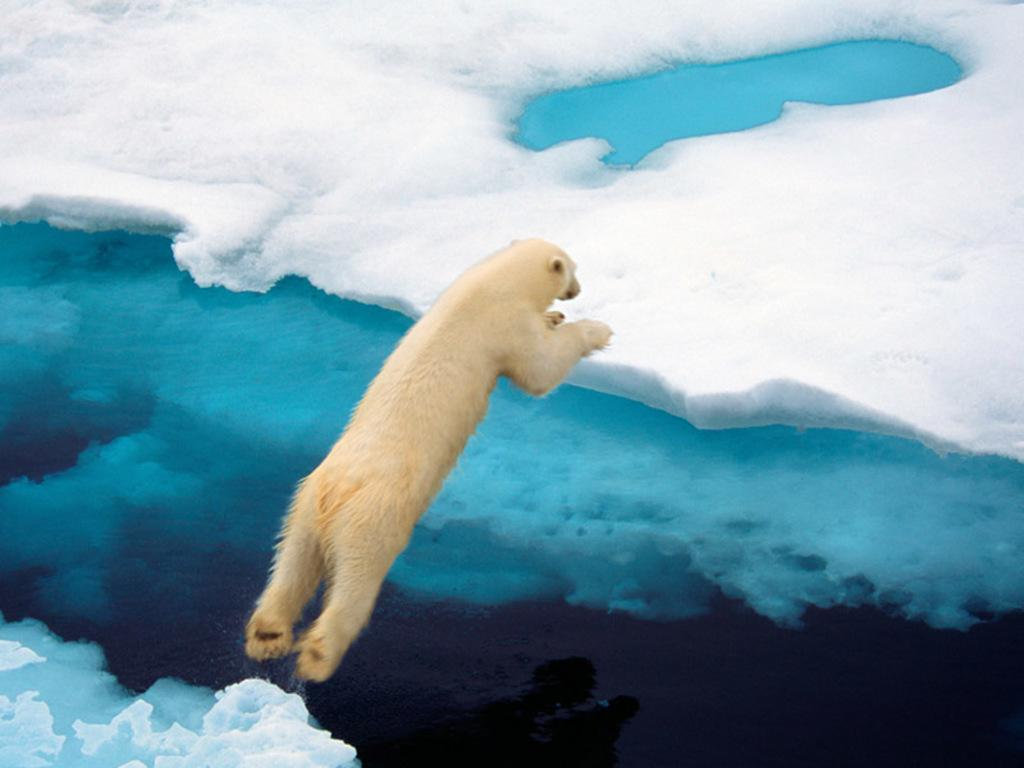What animal is present in the image? There is a bear in the image. What is the bear doing in the image? The bear is jumping from one part of the ice to another part. What type of jellyfish can be seen swimming in the water in the image? There is no water or jellyfish present in the image; it features a bear jumping on ice. 